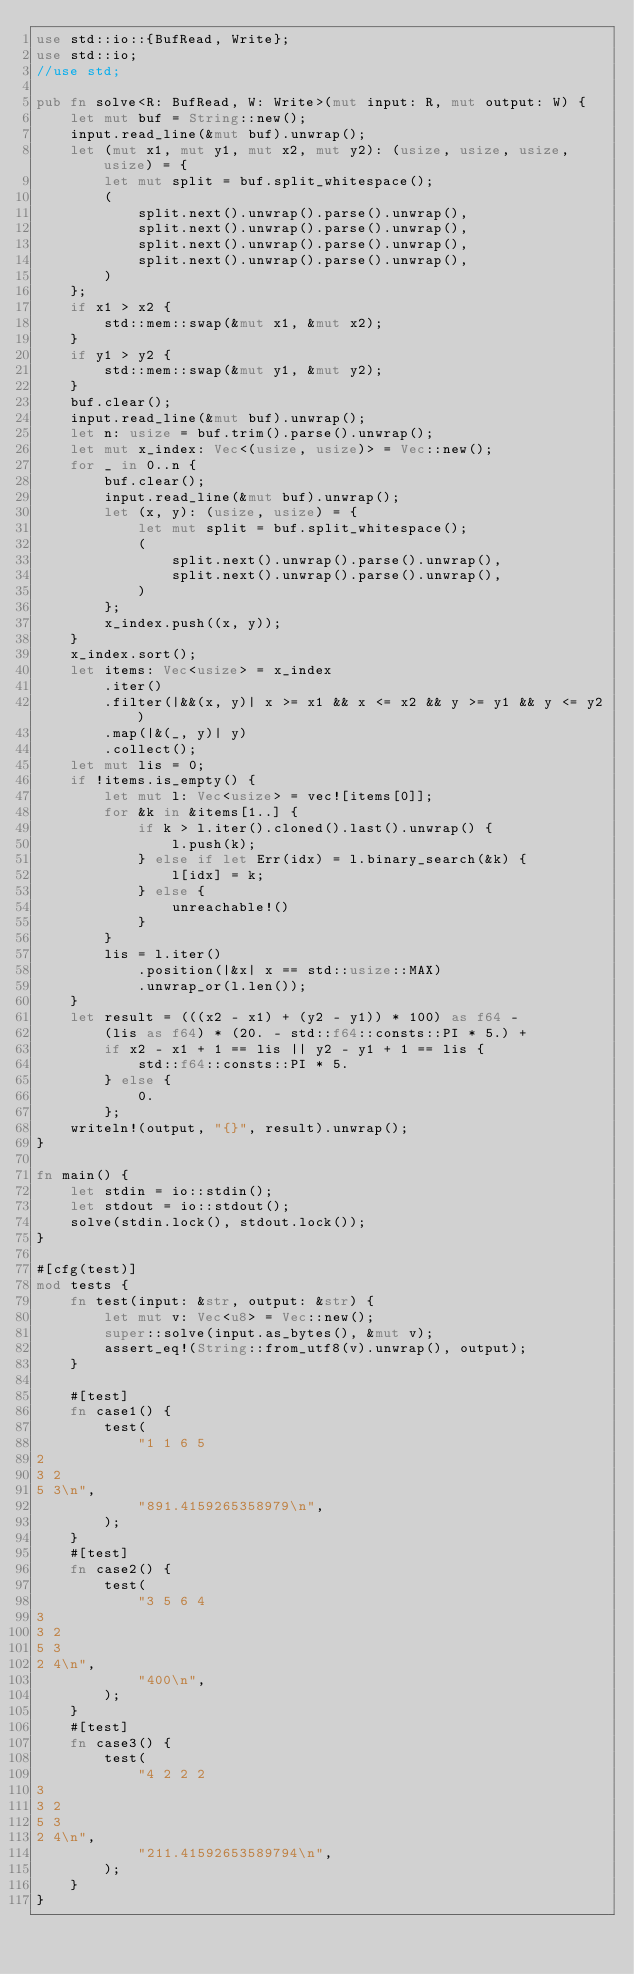Convert code to text. <code><loc_0><loc_0><loc_500><loc_500><_Rust_>use std::io::{BufRead, Write};
use std::io;
//use std;

pub fn solve<R: BufRead, W: Write>(mut input: R, mut output: W) {
    let mut buf = String::new();
    input.read_line(&mut buf).unwrap();
    let (mut x1, mut y1, mut x2, mut y2): (usize, usize, usize, usize) = {
        let mut split = buf.split_whitespace();
        (
            split.next().unwrap().parse().unwrap(),
            split.next().unwrap().parse().unwrap(),
            split.next().unwrap().parse().unwrap(),
            split.next().unwrap().parse().unwrap(),
        )
    };
    if x1 > x2 {
        std::mem::swap(&mut x1, &mut x2);
    }
    if y1 > y2 {
        std::mem::swap(&mut y1, &mut y2);
    }
    buf.clear();
    input.read_line(&mut buf).unwrap();
    let n: usize = buf.trim().parse().unwrap();
    let mut x_index: Vec<(usize, usize)> = Vec::new();
    for _ in 0..n {
        buf.clear();
        input.read_line(&mut buf).unwrap();
        let (x, y): (usize, usize) = {
            let mut split = buf.split_whitespace();
            (
                split.next().unwrap().parse().unwrap(),
                split.next().unwrap().parse().unwrap(),
            )
        };
        x_index.push((x, y));
    }
    x_index.sort();
    let items: Vec<usize> = x_index
        .iter()
        .filter(|&&(x, y)| x >= x1 && x <= x2 && y >= y1 && y <= y2)
        .map(|&(_, y)| y)
        .collect();
    let mut lis = 0;
    if !items.is_empty() {
        let mut l: Vec<usize> = vec![items[0]];
        for &k in &items[1..] {
            if k > l.iter().cloned().last().unwrap() {
                l.push(k);
            } else if let Err(idx) = l.binary_search(&k) {
                l[idx] = k;
            } else {
                unreachable!()
            }
        }
        lis = l.iter()
            .position(|&x| x == std::usize::MAX)
            .unwrap_or(l.len());
    }
    let result = (((x2 - x1) + (y2 - y1)) * 100) as f64 -
        (lis as f64) * (20. - std::f64::consts::PI * 5.) +
        if x2 - x1 + 1 == lis || y2 - y1 + 1 == lis {
            std::f64::consts::PI * 5.
        } else {
            0.
        };
    writeln!(output, "{}", result).unwrap();
}

fn main() {
    let stdin = io::stdin();
    let stdout = io::stdout();
    solve(stdin.lock(), stdout.lock());
}

#[cfg(test)]
mod tests {
    fn test(input: &str, output: &str) {
        let mut v: Vec<u8> = Vec::new();
        super::solve(input.as_bytes(), &mut v);
        assert_eq!(String::from_utf8(v).unwrap(), output);
    }

    #[test]
    fn case1() {
        test(
            "1 1 6 5
2
3 2
5 3\n",
            "891.4159265358979\n",
        );
    }
    #[test]
    fn case2() {
        test(
            "3 5 6 4
3
3 2
5 3
2 4\n",
            "400\n",
        );
    }
    #[test]
    fn case3() {
        test(
            "4 2 2 2
3
3 2
5 3
2 4\n",
            "211.41592653589794\n",
        );
    }
}
</code> 